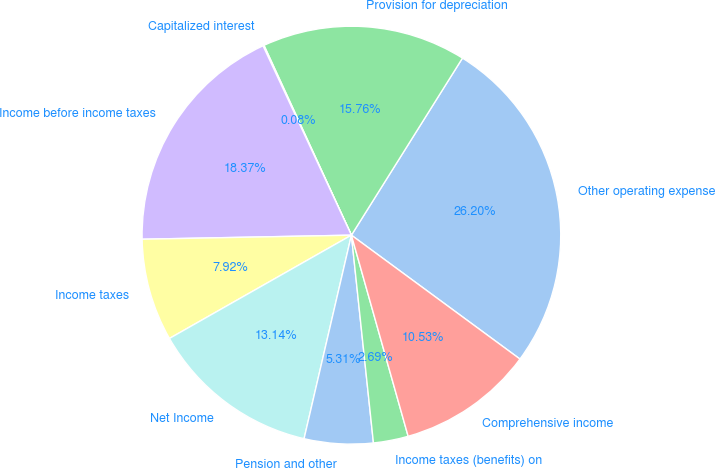Convert chart to OTSL. <chart><loc_0><loc_0><loc_500><loc_500><pie_chart><fcel>Other operating expense<fcel>Provision for depreciation<fcel>Capitalized interest<fcel>Income before income taxes<fcel>Income taxes<fcel>Net Income<fcel>Pension and other<fcel>Income taxes (benefits) on<fcel>Comprehensive income<nl><fcel>26.2%<fcel>15.76%<fcel>0.08%<fcel>18.37%<fcel>7.92%<fcel>13.14%<fcel>5.31%<fcel>2.69%<fcel>10.53%<nl></chart> 